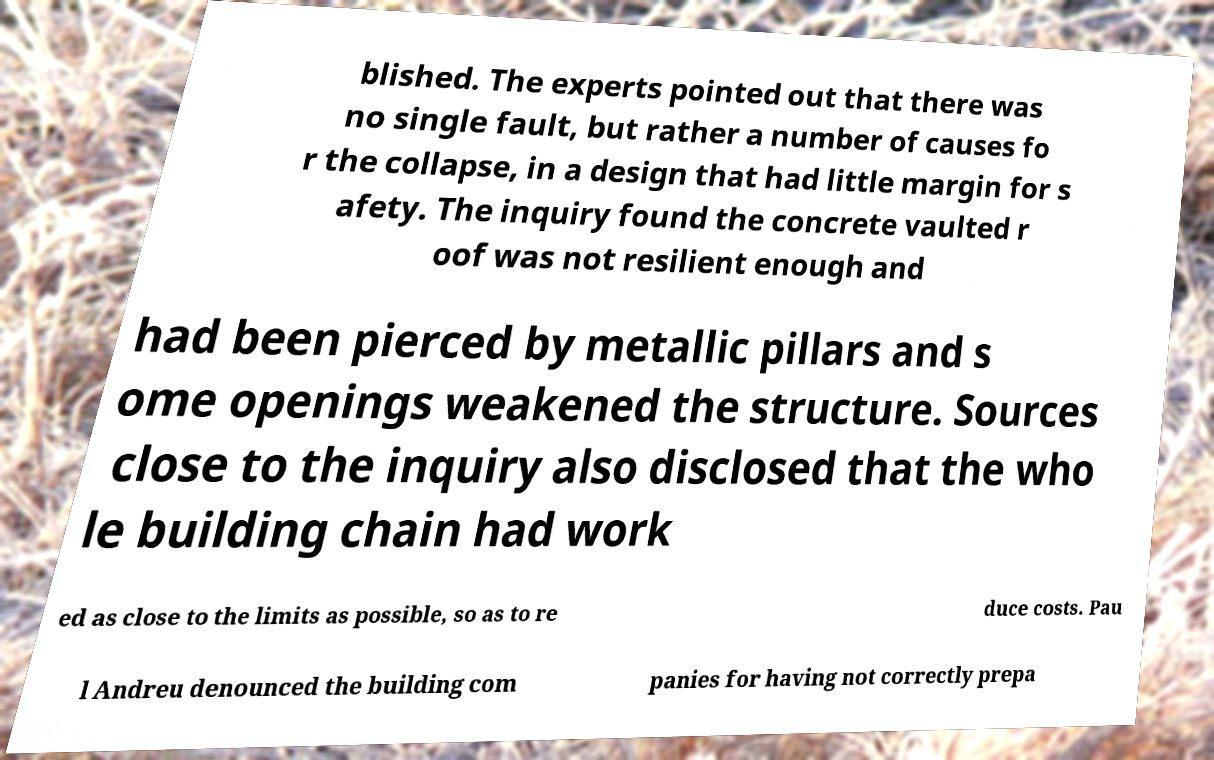Could you extract and type out the text from this image? blished. The experts pointed out that there was no single fault, but rather a number of causes fo r the collapse, in a design that had little margin for s afety. The inquiry found the concrete vaulted r oof was not resilient enough and had been pierced by metallic pillars and s ome openings weakened the structure. Sources close to the inquiry also disclosed that the who le building chain had work ed as close to the limits as possible, so as to re duce costs. Pau l Andreu denounced the building com panies for having not correctly prepa 